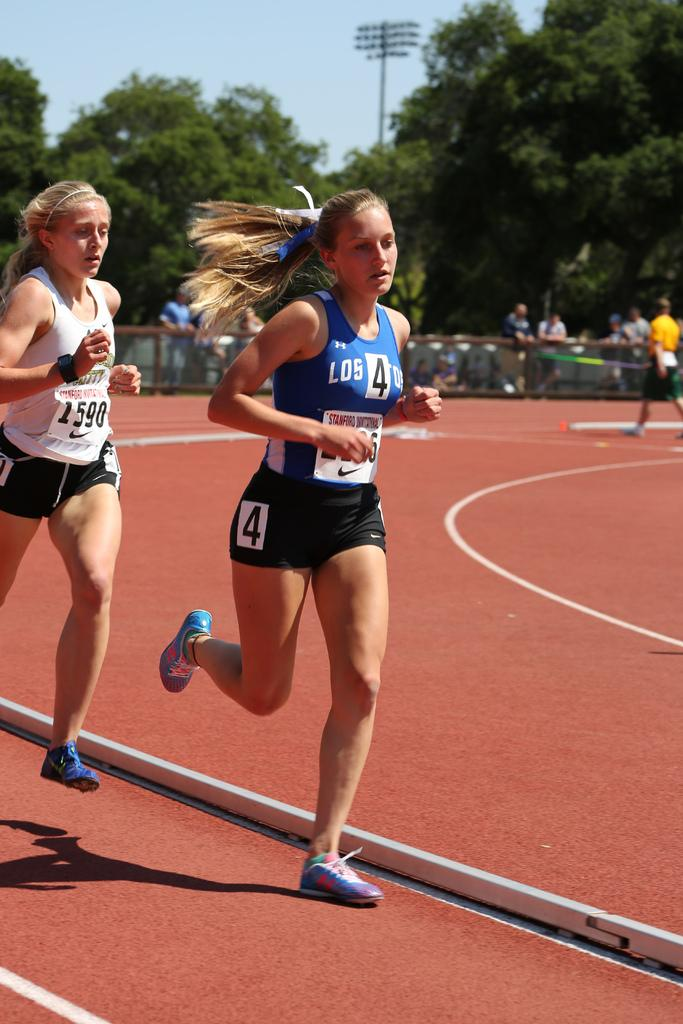Provide a one-sentence caption for the provided image. Woman running in a race with a sign taht says the number 4. 